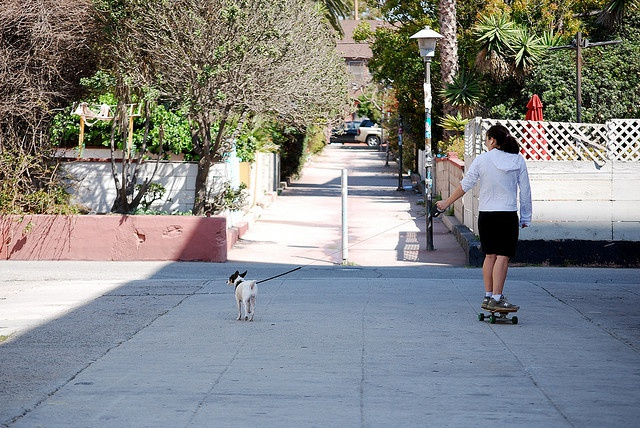Describe the objects in this image and their specific colors. I can see people in black, darkgray, and lavender tones, dog in black, darkgray, lightgray, and gray tones, car in black, lightgray, darkgray, and gray tones, skateboard in black, gray, and teal tones, and car in black, darkgray, navy, and blue tones in this image. 